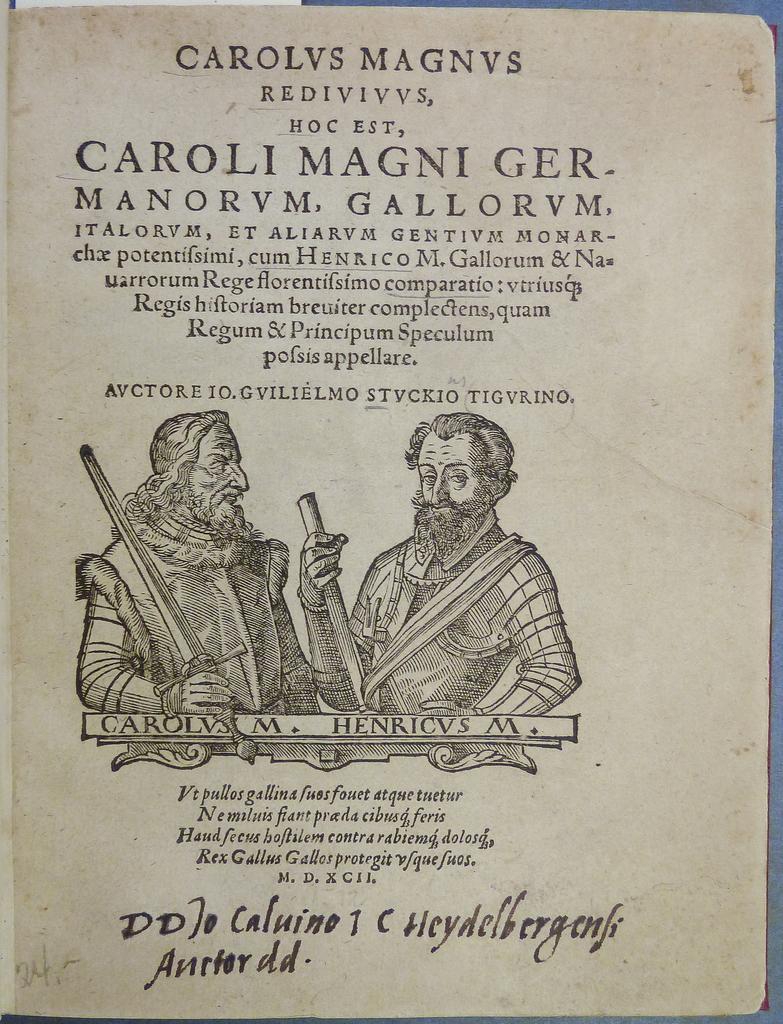How would you summarize this image in a sentence or two? In this image we can see first page of a book. 